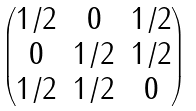<formula> <loc_0><loc_0><loc_500><loc_500>\begin{pmatrix} 1 / 2 & 0 & 1 / 2 \\ 0 & 1 / 2 & 1 / 2 \\ 1 / 2 & 1 / 2 & 0 \end{pmatrix}</formula> 